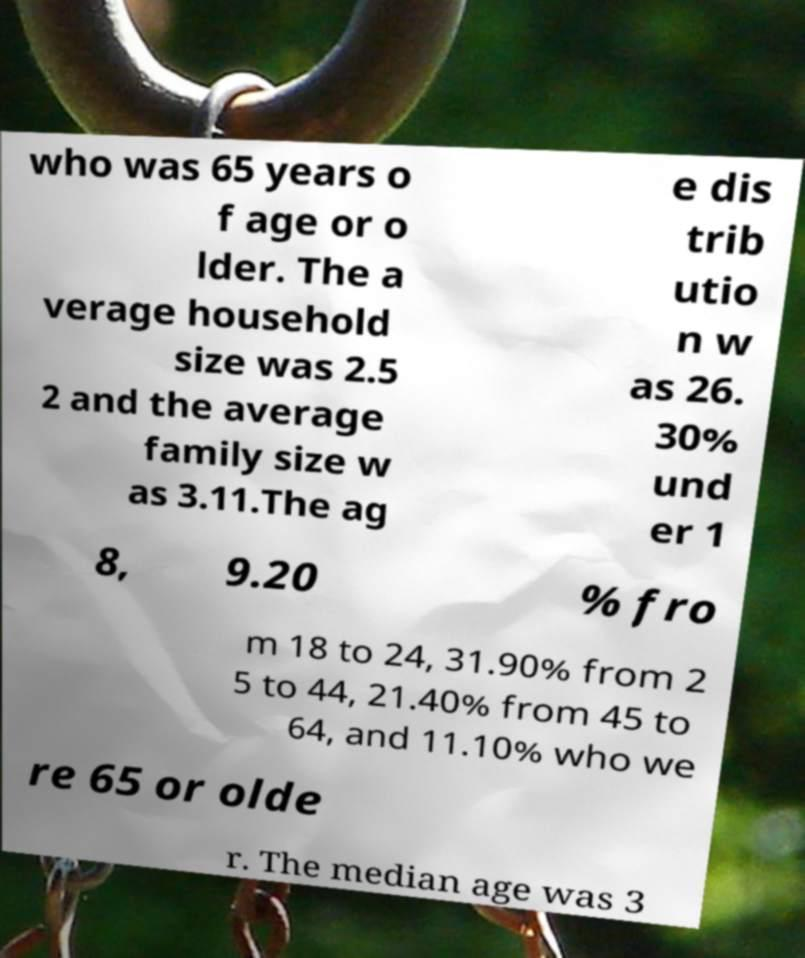For documentation purposes, I need the text within this image transcribed. Could you provide that? who was 65 years o f age or o lder. The a verage household size was 2.5 2 and the average family size w as 3.11.The ag e dis trib utio n w as 26. 30% und er 1 8, 9.20 % fro m 18 to 24, 31.90% from 2 5 to 44, 21.40% from 45 to 64, and 11.10% who we re 65 or olde r. The median age was 3 